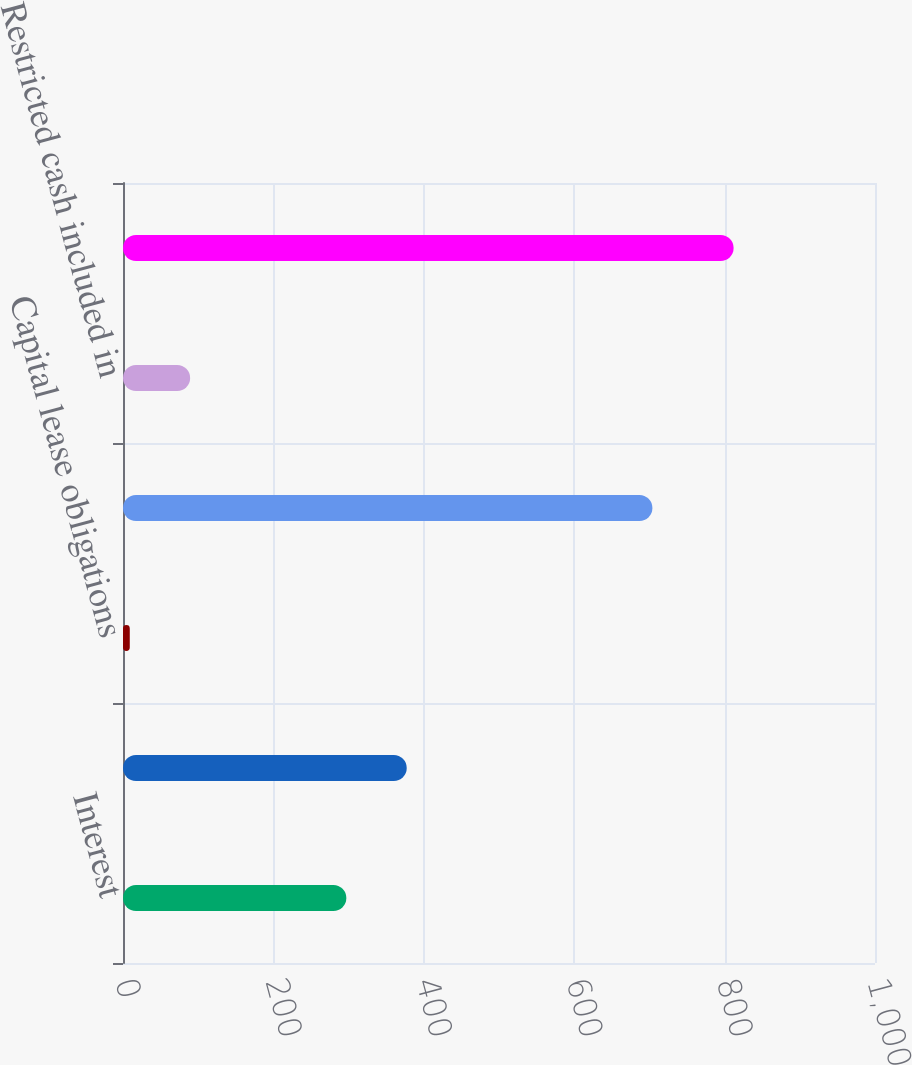Convert chart to OTSL. <chart><loc_0><loc_0><loc_500><loc_500><bar_chart><fcel>Interest<fcel>Income taxes (a)<fcel>Capital lease obligations<fcel>Cash and cash equivalents as<fcel>Restricted cash included in<fcel>Cash Cash Equivalents and<nl><fcel>297<fcel>377.3<fcel>9<fcel>704<fcel>89.3<fcel>812<nl></chart> 